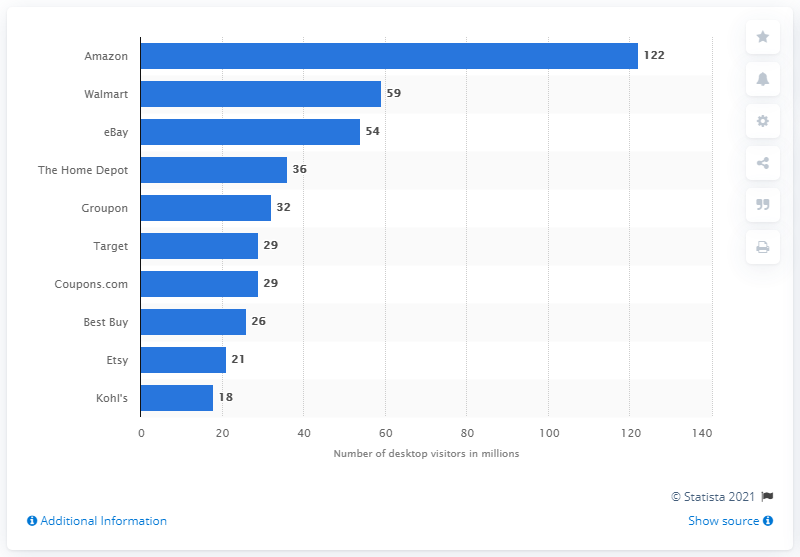Outline some significant characteristics in this image. In September 2018, Walmart's U.S. desktop audience was approximately 59 million. In September 2018, Amazon received approximately 122 PC visits. 